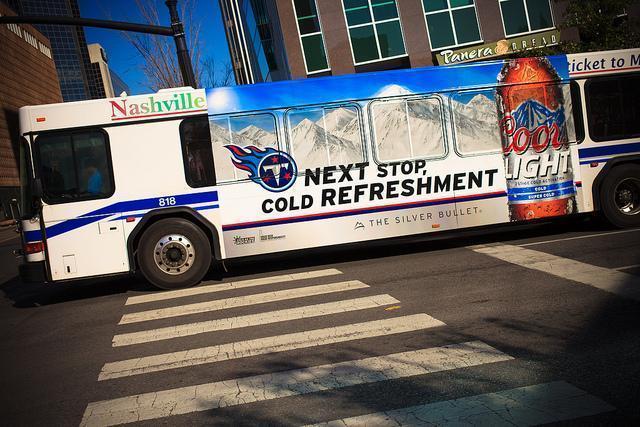Who is the road for?
Make your selection from the four choices given to correctly answer the question.
Options: Pedestrians, trucks, bicycles, drivers. Drivers. 